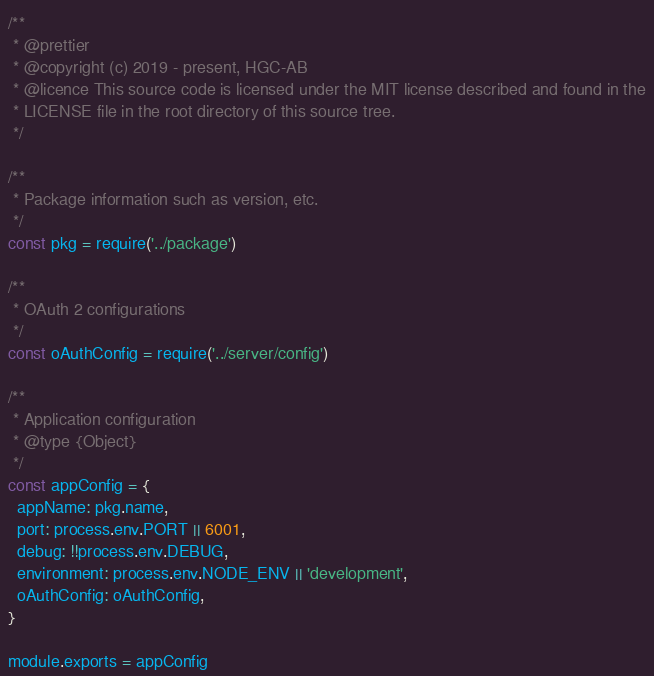Convert code to text. <code><loc_0><loc_0><loc_500><loc_500><_JavaScript_>/**
 * @prettier
 * @copyright (c) 2019 - present, HGC-AB
 * @licence This source code is licensed under the MIT license described and found in the
 * LICENSE file in the root directory of this source tree.
 */

/**
 * Package information such as version, etc.
 */
const pkg = require('../package')

/**
 * OAuth 2 configurations
 */
const oAuthConfig = require('../server/config')

/**
 * Application configuration
 * @type {Object}
 */
const appConfig = {
  appName: pkg.name,
  port: process.env.PORT || 6001,
  debug: !!process.env.DEBUG,
  environment: process.env.NODE_ENV || 'development',
  oAuthConfig: oAuthConfig,
}

module.exports = appConfig
</code> 